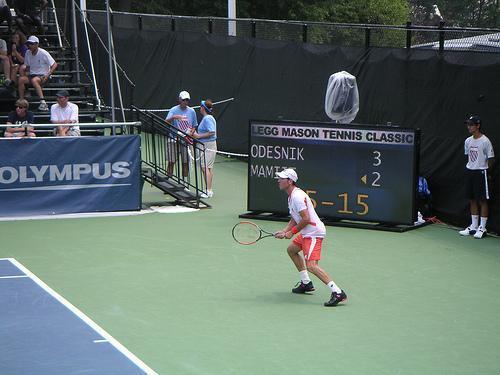How many tennis rackets are there?
Give a very brief answer. 1. 